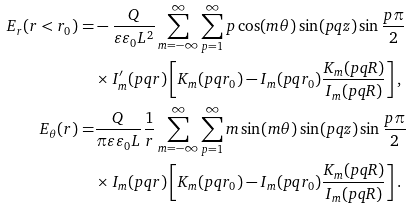Convert formula to latex. <formula><loc_0><loc_0><loc_500><loc_500>E _ { r } ( r < r _ { 0 } ) = & - \frac { Q } { \varepsilon \varepsilon _ { 0 } L ^ { 2 } } \sum _ { m = - \infty } ^ { \infty } \sum _ { p = 1 } ^ { \infty } p \cos ( m \theta ) \sin ( p q z ) \sin \frac { p \pi } { 2 } \\ & \times I _ { m } ^ { \prime } ( p q r ) \left [ K _ { m } ( p q r _ { 0 } ) - I _ { m } ( p q r _ { 0 } ) \frac { K _ { m } ( p q R ) } { I _ { m } ( p q R ) } \right ] , \\ E _ { \theta } ( r ) = & \frac { Q } { \pi \varepsilon \varepsilon _ { 0 } L } \frac { 1 } { r } \sum _ { m = - \infty } ^ { \infty } \sum _ { p = 1 } ^ { \infty } m \sin ( m \theta ) \sin ( p q z ) \sin \frac { p \pi } { 2 } \\ & \times I _ { m } ( p q r ) \left [ K _ { m } ( p q r _ { 0 } ) - I _ { m } ( p q r _ { 0 } ) \frac { K _ { m } ( p q R ) } { I _ { m } ( p q R ) } \right ] .</formula> 